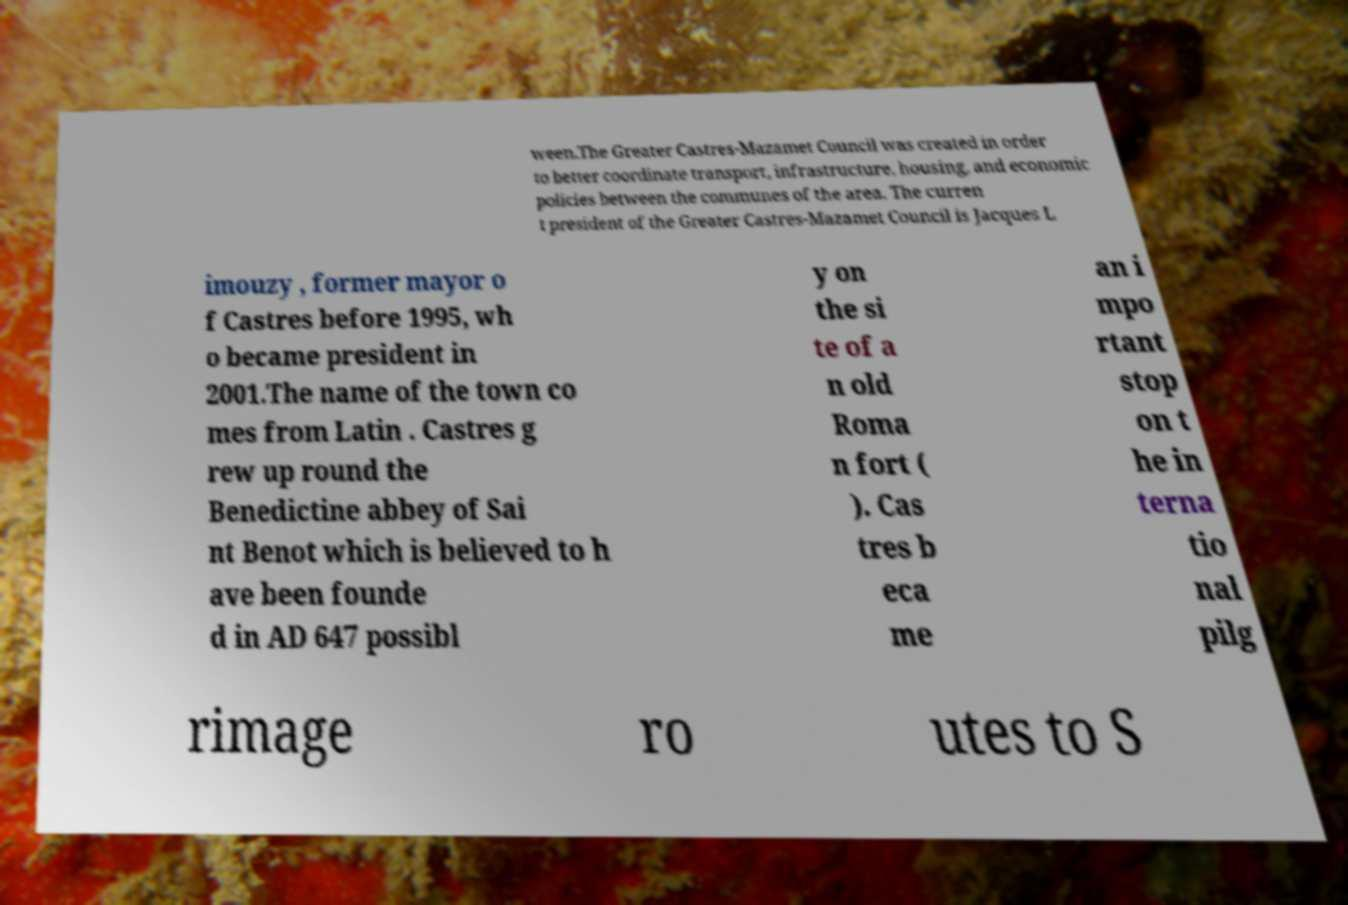Could you extract and type out the text from this image? ween.The Greater Castres-Mazamet Council was created in order to better coordinate transport, infrastructure, housing, and economic policies between the communes of the area. The curren t president of the Greater Castres-Mazamet Council is Jacques L imouzy , former mayor o f Castres before 1995, wh o became president in 2001.The name of the town co mes from Latin . Castres g rew up round the Benedictine abbey of Sai nt Benot which is believed to h ave been founde d in AD 647 possibl y on the si te of a n old Roma n fort ( ). Cas tres b eca me an i mpo rtant stop on t he in terna tio nal pilg rimage ro utes to S 